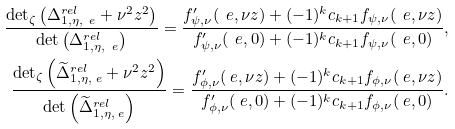Convert formula to latex. <formula><loc_0><loc_0><loc_500><loc_500>\frac { \det _ { \zeta } \left ( \Delta _ { 1 , \eta , \ e } ^ { r e l } + \nu ^ { 2 } z ^ { 2 } \right ) } { \det \left ( \Delta _ { 1 , \eta , \ e } ^ { r e l } \right ) } = \frac { f ^ { \prime } _ { \psi , \nu } ( \ e , \nu z ) + ( - 1 ) ^ { k } c _ { k + 1 } f _ { \psi , \nu } ( \ e , \nu z ) } { f ^ { \prime } _ { \psi , \nu } ( \ e , 0 ) + ( - 1 ) ^ { k } c _ { k + 1 } f _ { \psi , \nu } ( \ e , 0 ) } , \\ \frac { \det _ { \zeta } \left ( \widetilde { \Delta } _ { 1 , \eta , \ e } ^ { r e l } + \nu ^ { 2 } z ^ { 2 } \right ) } { \det \left ( \widetilde { \Delta } _ { 1 , \eta , \ e } ^ { r e l } \right ) } = \frac { f ^ { \prime } _ { \phi , \nu } ( \ e , \nu z ) + ( - 1 ) ^ { k } c _ { k + 1 } f _ { \phi , \nu } ( \ e , \nu z ) } { f ^ { \prime } _ { \phi , \nu } ( \ e , 0 ) + ( - 1 ) ^ { k } c _ { k + 1 } f _ { \phi , \nu } ( \ e , 0 ) } .</formula> 